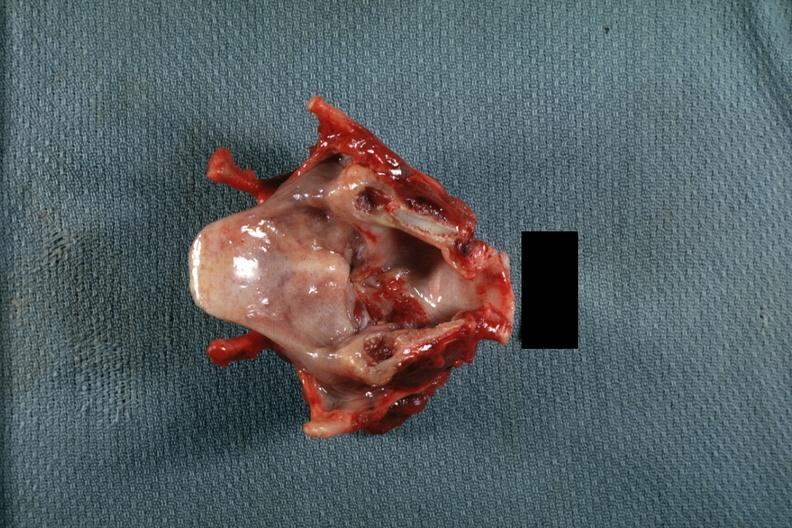s larynx present?
Answer the question using a single word or phrase. Yes 